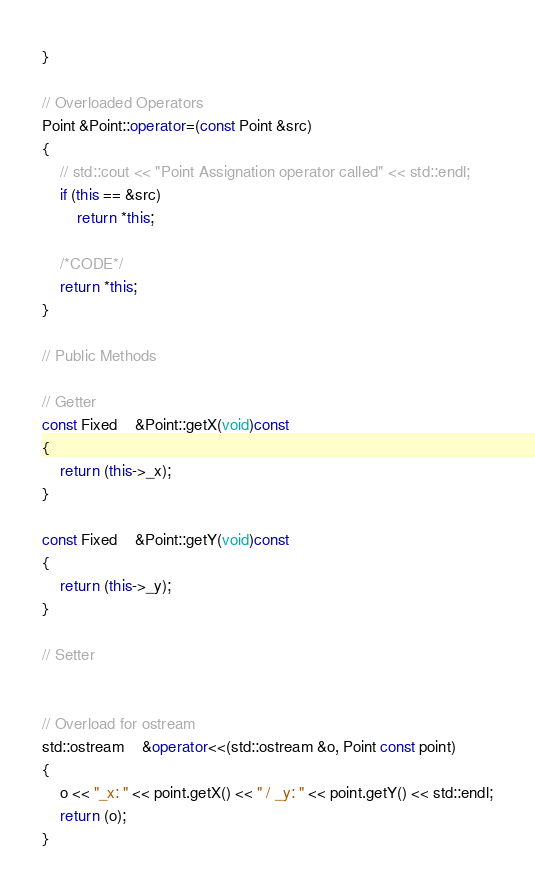<code> <loc_0><loc_0><loc_500><loc_500><_C++_>}

// Overloaded Operators
Point &Point::operator=(const Point &src)
{
	// std::cout << "Point Assignation operator called" << std::endl;
	if (this == &src)
		return *this;

	/*CODE*/
	return *this;
}

// Public Methods

// Getter
const Fixed	&Point::getX(void)const
{
	return (this->_x);
}

const Fixed	&Point::getY(void)const
{
	return (this->_y);
}

// Setter


// Overload for ostream
std::ostream	&operator<<(std::ostream &o, Point const point)
{
	o << "_x: " << point.getX() << " / _y: " << point.getY() << std::endl;
	return (o);
}
</code> 